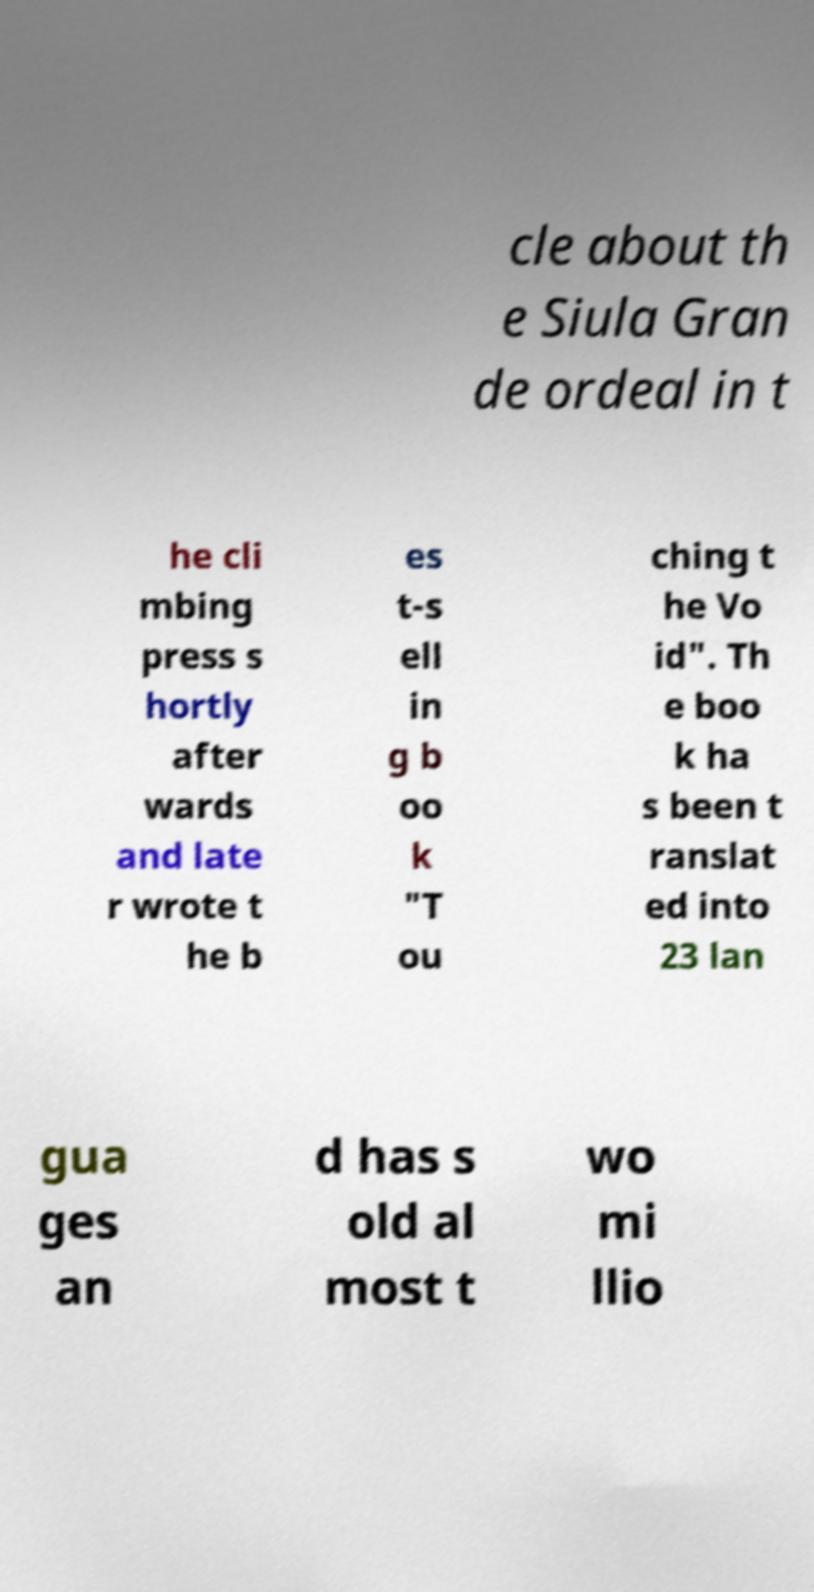For documentation purposes, I need the text within this image transcribed. Could you provide that? cle about th e Siula Gran de ordeal in t he cli mbing press s hortly after wards and late r wrote t he b es t-s ell in g b oo k "T ou ching t he Vo id". Th e boo k ha s been t ranslat ed into 23 lan gua ges an d has s old al most t wo mi llio 